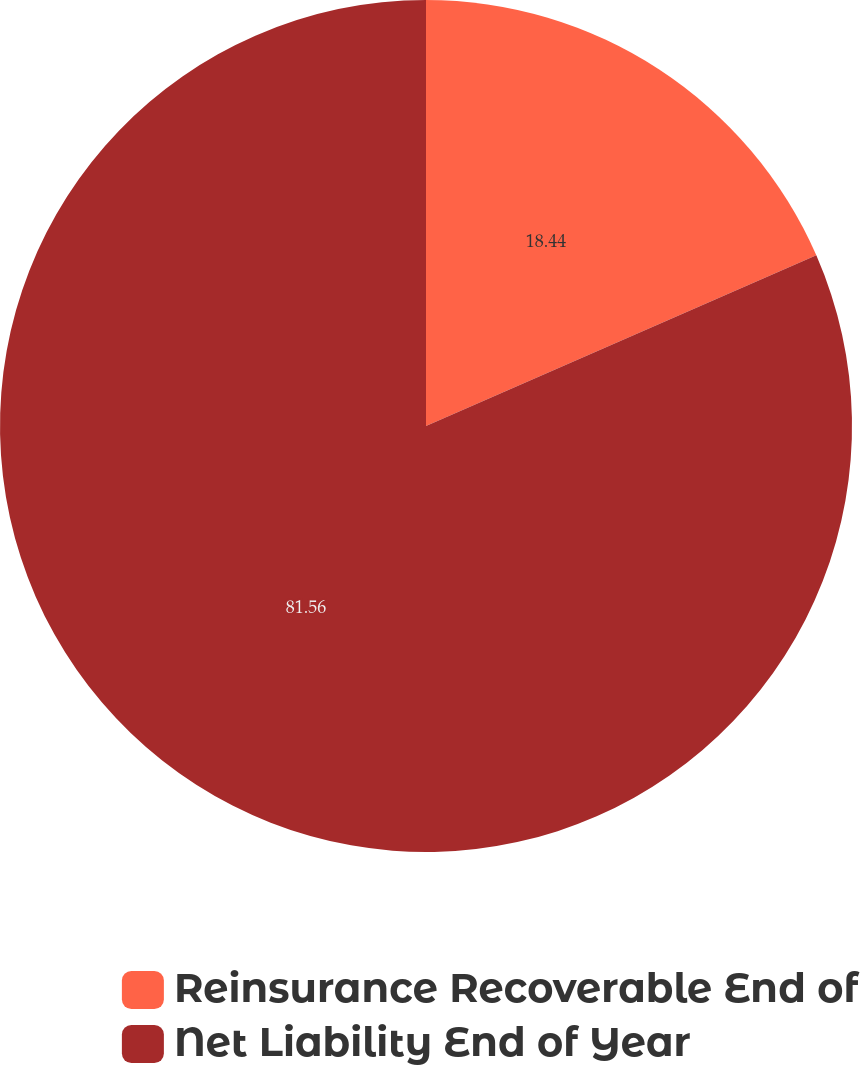<chart> <loc_0><loc_0><loc_500><loc_500><pie_chart><fcel>Reinsurance Recoverable End of<fcel>Net Liability End of Year<nl><fcel>18.44%<fcel>81.56%<nl></chart> 